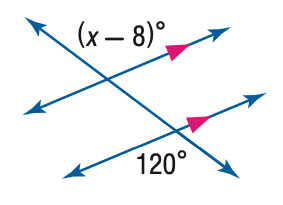Question: Find the value of x in the figure below.
Choices:
A. 68
B. 112
C. 120
D. 128
Answer with the letter. Answer: D 